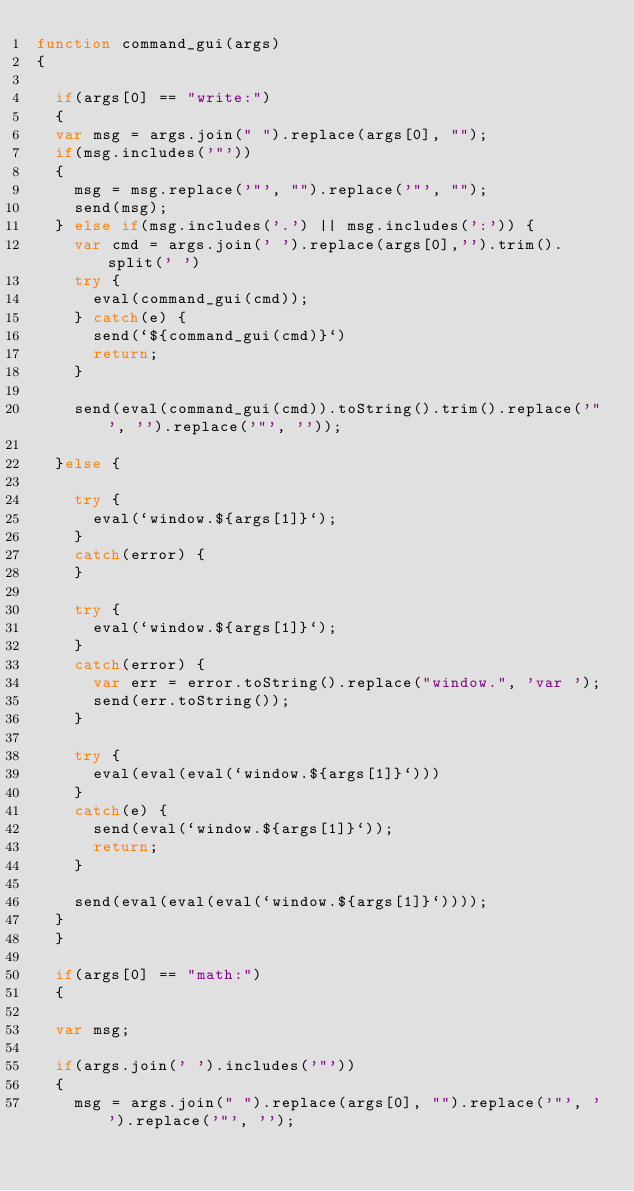Convert code to text. <code><loc_0><loc_0><loc_500><loc_500><_JavaScript_>function command_gui(args)
{

  if(args[0] == "write:")
  {
  var msg = args.join(" ").replace(args[0], "");
  if(msg.includes('"'))
  {
    msg = msg.replace('"', "").replace('"', "");
    send(msg);
  } else if(msg.includes('.') || msg.includes(':')) {
    var cmd = args.join(' ').replace(args[0],'').trim().split(' ')
    try {
      eval(command_gui(cmd));
    } catch(e) {
      send(`${command_gui(cmd)}`)
      return;
    }
    
    send(eval(command_gui(cmd)).toString().trim().replace('"', '').replace('"', ''));

  }else {
  
    try {
      eval(`window.${args[1]}`);
    }
    catch(error) {
    }
  
    try {
      eval(`window.${args[1]}`);
    }
    catch(error) {
      var err = error.toString().replace("window.", 'var ');
      send(err.toString());
    }
    
    try { 
      eval(eval(eval(`window.${args[1]}`)))
    }
    catch(e) {
      send(eval(`window.${args[1]}`));
      return;
    }

    send(eval(eval(eval(`window.${args[1]}`))));
  }
  }
  
  if(args[0] == "math:")
  {
  
  var msg;
  
  if(args.join(' ').includes('"'))
  {
    msg = args.join(" ").replace(args[0], "").replace('"', '').replace('"', '');</code> 